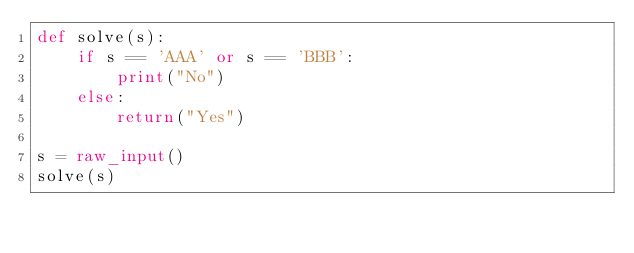<code> <loc_0><loc_0><loc_500><loc_500><_Python_>def solve(s):
    if s == 'AAA' or s == 'BBB':
        print("No")
    else:
        return("Yes")

s = raw_input()
solve(s)
</code> 